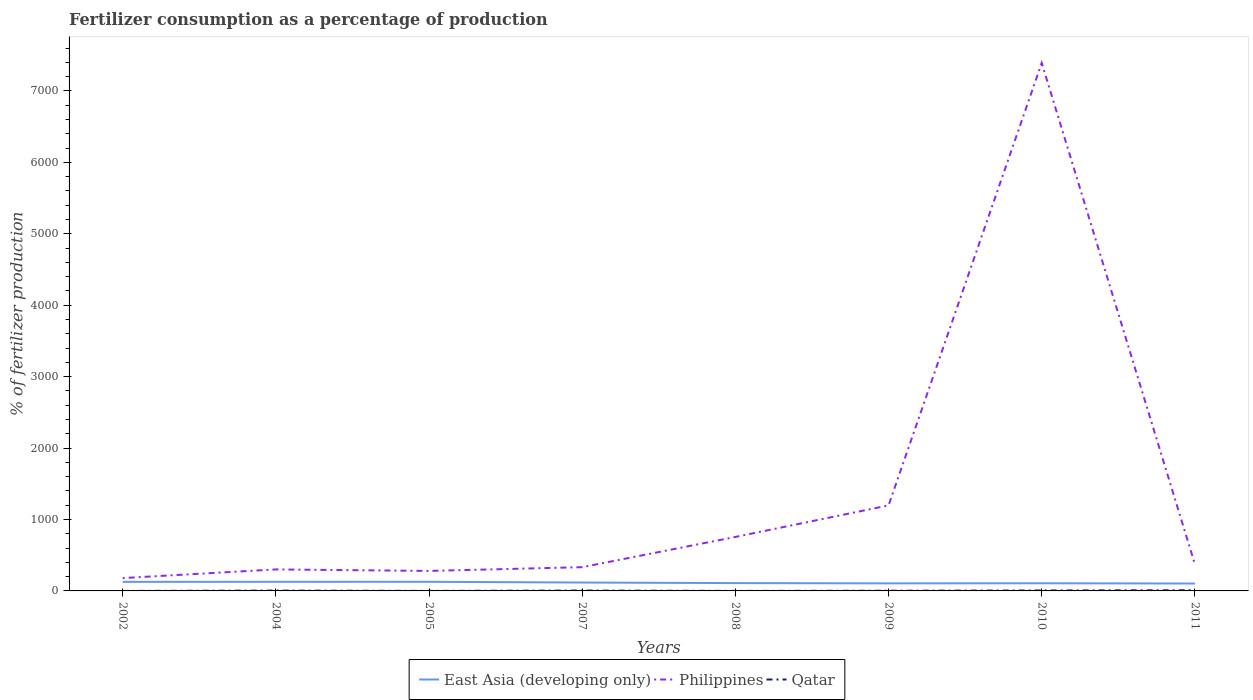How many different coloured lines are there?
Your answer should be compact. 3. Across all years, what is the maximum percentage of fertilizers consumed in Qatar?
Make the answer very short. 0.06. What is the total percentage of fertilizers consumed in Qatar in the graph?
Ensure brevity in your answer.  -5.1. What is the difference between the highest and the second highest percentage of fertilizers consumed in Qatar?
Offer a very short reply. 9.68. What is the difference between the highest and the lowest percentage of fertilizers consumed in Philippines?
Your answer should be very brief. 1. How many lines are there?
Your answer should be very brief. 3. How many years are there in the graph?
Keep it short and to the point. 8. Does the graph contain any zero values?
Ensure brevity in your answer.  No. Does the graph contain grids?
Your answer should be compact. No. Where does the legend appear in the graph?
Give a very brief answer. Bottom center. How many legend labels are there?
Ensure brevity in your answer.  3. How are the legend labels stacked?
Provide a short and direct response. Horizontal. What is the title of the graph?
Offer a terse response. Fertilizer consumption as a percentage of production. Does "France" appear as one of the legend labels in the graph?
Keep it short and to the point. No. What is the label or title of the Y-axis?
Ensure brevity in your answer.  % of fertilizer production. What is the % of fertilizer production of East Asia (developing only) in 2002?
Offer a very short reply. 127.14. What is the % of fertilizer production of Philippines in 2002?
Your answer should be very brief. 179.9. What is the % of fertilizer production in Qatar in 2002?
Your answer should be very brief. 0.06. What is the % of fertilizer production of East Asia (developing only) in 2004?
Provide a succinct answer. 127.47. What is the % of fertilizer production in Philippines in 2004?
Your response must be concise. 301.04. What is the % of fertilizer production in Qatar in 2004?
Give a very brief answer. 4.79. What is the % of fertilizer production of East Asia (developing only) in 2005?
Your response must be concise. 127.76. What is the % of fertilizer production of Philippines in 2005?
Keep it short and to the point. 280.04. What is the % of fertilizer production of Qatar in 2005?
Your response must be concise. 0.54. What is the % of fertilizer production of East Asia (developing only) in 2007?
Offer a terse response. 117.36. What is the % of fertilizer production in Philippines in 2007?
Provide a short and direct response. 332.59. What is the % of fertilizer production in Qatar in 2007?
Your answer should be very brief. 5.16. What is the % of fertilizer production in East Asia (developing only) in 2008?
Ensure brevity in your answer.  109.65. What is the % of fertilizer production in Philippines in 2008?
Your answer should be very brief. 755.74. What is the % of fertilizer production in Qatar in 2008?
Give a very brief answer. 0.26. What is the % of fertilizer production in East Asia (developing only) in 2009?
Make the answer very short. 105.86. What is the % of fertilizer production in Philippines in 2009?
Your answer should be very brief. 1197.15. What is the % of fertilizer production in Qatar in 2009?
Give a very brief answer. 2.78. What is the % of fertilizer production of East Asia (developing only) in 2010?
Provide a succinct answer. 107.14. What is the % of fertilizer production in Philippines in 2010?
Offer a very short reply. 7391.18. What is the % of fertilizer production of Qatar in 2010?
Offer a very short reply. 6.17. What is the % of fertilizer production in East Asia (developing only) in 2011?
Keep it short and to the point. 103.65. What is the % of fertilizer production in Philippines in 2011?
Your answer should be very brief. 374.92. What is the % of fertilizer production in Qatar in 2011?
Your response must be concise. 9.75. Across all years, what is the maximum % of fertilizer production in East Asia (developing only)?
Offer a very short reply. 127.76. Across all years, what is the maximum % of fertilizer production of Philippines?
Your response must be concise. 7391.18. Across all years, what is the maximum % of fertilizer production in Qatar?
Your response must be concise. 9.75. Across all years, what is the minimum % of fertilizer production in East Asia (developing only)?
Offer a very short reply. 103.65. Across all years, what is the minimum % of fertilizer production in Philippines?
Provide a succinct answer. 179.9. Across all years, what is the minimum % of fertilizer production in Qatar?
Make the answer very short. 0.06. What is the total % of fertilizer production of East Asia (developing only) in the graph?
Ensure brevity in your answer.  926.02. What is the total % of fertilizer production of Philippines in the graph?
Give a very brief answer. 1.08e+04. What is the total % of fertilizer production of Qatar in the graph?
Offer a terse response. 29.52. What is the difference between the % of fertilizer production in East Asia (developing only) in 2002 and that in 2004?
Make the answer very short. -0.33. What is the difference between the % of fertilizer production in Philippines in 2002 and that in 2004?
Provide a succinct answer. -121.14. What is the difference between the % of fertilizer production in Qatar in 2002 and that in 2004?
Your answer should be very brief. -4.73. What is the difference between the % of fertilizer production in East Asia (developing only) in 2002 and that in 2005?
Offer a very short reply. -0.62. What is the difference between the % of fertilizer production in Philippines in 2002 and that in 2005?
Keep it short and to the point. -100.14. What is the difference between the % of fertilizer production in Qatar in 2002 and that in 2005?
Provide a succinct answer. -0.47. What is the difference between the % of fertilizer production in East Asia (developing only) in 2002 and that in 2007?
Provide a succinct answer. 9.77. What is the difference between the % of fertilizer production in Philippines in 2002 and that in 2007?
Your response must be concise. -152.69. What is the difference between the % of fertilizer production in Qatar in 2002 and that in 2007?
Your answer should be very brief. -5.1. What is the difference between the % of fertilizer production in East Asia (developing only) in 2002 and that in 2008?
Offer a terse response. 17.49. What is the difference between the % of fertilizer production of Philippines in 2002 and that in 2008?
Give a very brief answer. -575.84. What is the difference between the % of fertilizer production of Qatar in 2002 and that in 2008?
Offer a terse response. -0.2. What is the difference between the % of fertilizer production in East Asia (developing only) in 2002 and that in 2009?
Give a very brief answer. 21.28. What is the difference between the % of fertilizer production of Philippines in 2002 and that in 2009?
Make the answer very short. -1017.25. What is the difference between the % of fertilizer production in Qatar in 2002 and that in 2009?
Give a very brief answer. -2.71. What is the difference between the % of fertilizer production in East Asia (developing only) in 2002 and that in 2010?
Provide a succinct answer. 20. What is the difference between the % of fertilizer production in Philippines in 2002 and that in 2010?
Offer a very short reply. -7211.28. What is the difference between the % of fertilizer production of Qatar in 2002 and that in 2010?
Ensure brevity in your answer.  -6.11. What is the difference between the % of fertilizer production in East Asia (developing only) in 2002 and that in 2011?
Offer a very short reply. 23.48. What is the difference between the % of fertilizer production of Philippines in 2002 and that in 2011?
Make the answer very short. -195.02. What is the difference between the % of fertilizer production of Qatar in 2002 and that in 2011?
Keep it short and to the point. -9.68. What is the difference between the % of fertilizer production in East Asia (developing only) in 2004 and that in 2005?
Your answer should be compact. -0.29. What is the difference between the % of fertilizer production in Philippines in 2004 and that in 2005?
Offer a very short reply. 21. What is the difference between the % of fertilizer production in Qatar in 2004 and that in 2005?
Your answer should be very brief. 4.26. What is the difference between the % of fertilizer production of East Asia (developing only) in 2004 and that in 2007?
Give a very brief answer. 10.11. What is the difference between the % of fertilizer production in Philippines in 2004 and that in 2007?
Your answer should be compact. -31.55. What is the difference between the % of fertilizer production of Qatar in 2004 and that in 2007?
Your answer should be compact. -0.37. What is the difference between the % of fertilizer production in East Asia (developing only) in 2004 and that in 2008?
Provide a succinct answer. 17.82. What is the difference between the % of fertilizer production in Philippines in 2004 and that in 2008?
Your response must be concise. -454.7. What is the difference between the % of fertilizer production in Qatar in 2004 and that in 2008?
Offer a very short reply. 4.53. What is the difference between the % of fertilizer production of East Asia (developing only) in 2004 and that in 2009?
Ensure brevity in your answer.  21.61. What is the difference between the % of fertilizer production of Philippines in 2004 and that in 2009?
Your answer should be compact. -896.11. What is the difference between the % of fertilizer production in Qatar in 2004 and that in 2009?
Provide a short and direct response. 2.02. What is the difference between the % of fertilizer production in East Asia (developing only) in 2004 and that in 2010?
Offer a very short reply. 20.33. What is the difference between the % of fertilizer production in Philippines in 2004 and that in 2010?
Offer a terse response. -7090.14. What is the difference between the % of fertilizer production in Qatar in 2004 and that in 2010?
Provide a short and direct response. -1.38. What is the difference between the % of fertilizer production in East Asia (developing only) in 2004 and that in 2011?
Provide a short and direct response. 23.81. What is the difference between the % of fertilizer production of Philippines in 2004 and that in 2011?
Provide a short and direct response. -73.88. What is the difference between the % of fertilizer production of Qatar in 2004 and that in 2011?
Provide a short and direct response. -4.96. What is the difference between the % of fertilizer production in East Asia (developing only) in 2005 and that in 2007?
Offer a very short reply. 10.39. What is the difference between the % of fertilizer production of Philippines in 2005 and that in 2007?
Provide a short and direct response. -52.55. What is the difference between the % of fertilizer production of Qatar in 2005 and that in 2007?
Keep it short and to the point. -4.63. What is the difference between the % of fertilizer production in East Asia (developing only) in 2005 and that in 2008?
Keep it short and to the point. 18.11. What is the difference between the % of fertilizer production of Philippines in 2005 and that in 2008?
Your response must be concise. -475.7. What is the difference between the % of fertilizer production of Qatar in 2005 and that in 2008?
Your response must be concise. 0.28. What is the difference between the % of fertilizer production in East Asia (developing only) in 2005 and that in 2009?
Provide a short and direct response. 21.9. What is the difference between the % of fertilizer production of Philippines in 2005 and that in 2009?
Keep it short and to the point. -917.11. What is the difference between the % of fertilizer production of Qatar in 2005 and that in 2009?
Offer a terse response. -2.24. What is the difference between the % of fertilizer production in East Asia (developing only) in 2005 and that in 2010?
Your answer should be compact. 20.62. What is the difference between the % of fertilizer production of Philippines in 2005 and that in 2010?
Provide a short and direct response. -7111.14. What is the difference between the % of fertilizer production in Qatar in 2005 and that in 2010?
Offer a terse response. -5.64. What is the difference between the % of fertilizer production in East Asia (developing only) in 2005 and that in 2011?
Your answer should be compact. 24.1. What is the difference between the % of fertilizer production of Philippines in 2005 and that in 2011?
Give a very brief answer. -94.88. What is the difference between the % of fertilizer production in Qatar in 2005 and that in 2011?
Provide a succinct answer. -9.21. What is the difference between the % of fertilizer production in East Asia (developing only) in 2007 and that in 2008?
Give a very brief answer. 7.72. What is the difference between the % of fertilizer production in Philippines in 2007 and that in 2008?
Make the answer very short. -423.15. What is the difference between the % of fertilizer production in Qatar in 2007 and that in 2008?
Your answer should be very brief. 4.9. What is the difference between the % of fertilizer production of East Asia (developing only) in 2007 and that in 2009?
Provide a succinct answer. 11.51. What is the difference between the % of fertilizer production of Philippines in 2007 and that in 2009?
Your answer should be very brief. -864.56. What is the difference between the % of fertilizer production of Qatar in 2007 and that in 2009?
Your answer should be compact. 2.38. What is the difference between the % of fertilizer production in East Asia (developing only) in 2007 and that in 2010?
Ensure brevity in your answer.  10.22. What is the difference between the % of fertilizer production in Philippines in 2007 and that in 2010?
Make the answer very short. -7058.59. What is the difference between the % of fertilizer production of Qatar in 2007 and that in 2010?
Offer a terse response. -1.01. What is the difference between the % of fertilizer production of East Asia (developing only) in 2007 and that in 2011?
Keep it short and to the point. 13.71. What is the difference between the % of fertilizer production in Philippines in 2007 and that in 2011?
Offer a very short reply. -42.33. What is the difference between the % of fertilizer production of Qatar in 2007 and that in 2011?
Your answer should be very brief. -4.59. What is the difference between the % of fertilizer production of East Asia (developing only) in 2008 and that in 2009?
Offer a very short reply. 3.79. What is the difference between the % of fertilizer production of Philippines in 2008 and that in 2009?
Offer a very short reply. -441.41. What is the difference between the % of fertilizer production in Qatar in 2008 and that in 2009?
Ensure brevity in your answer.  -2.52. What is the difference between the % of fertilizer production in East Asia (developing only) in 2008 and that in 2010?
Your answer should be very brief. 2.51. What is the difference between the % of fertilizer production of Philippines in 2008 and that in 2010?
Give a very brief answer. -6635.44. What is the difference between the % of fertilizer production in Qatar in 2008 and that in 2010?
Offer a very short reply. -5.91. What is the difference between the % of fertilizer production of East Asia (developing only) in 2008 and that in 2011?
Make the answer very short. 5.99. What is the difference between the % of fertilizer production in Philippines in 2008 and that in 2011?
Ensure brevity in your answer.  380.82. What is the difference between the % of fertilizer production in Qatar in 2008 and that in 2011?
Keep it short and to the point. -9.49. What is the difference between the % of fertilizer production of East Asia (developing only) in 2009 and that in 2010?
Provide a succinct answer. -1.29. What is the difference between the % of fertilizer production in Philippines in 2009 and that in 2010?
Offer a terse response. -6194.03. What is the difference between the % of fertilizer production in Qatar in 2009 and that in 2010?
Your response must be concise. -3.4. What is the difference between the % of fertilizer production of East Asia (developing only) in 2009 and that in 2011?
Offer a very short reply. 2.2. What is the difference between the % of fertilizer production in Philippines in 2009 and that in 2011?
Provide a short and direct response. 822.23. What is the difference between the % of fertilizer production in Qatar in 2009 and that in 2011?
Ensure brevity in your answer.  -6.97. What is the difference between the % of fertilizer production of East Asia (developing only) in 2010 and that in 2011?
Ensure brevity in your answer.  3.49. What is the difference between the % of fertilizer production of Philippines in 2010 and that in 2011?
Ensure brevity in your answer.  7016.26. What is the difference between the % of fertilizer production in Qatar in 2010 and that in 2011?
Keep it short and to the point. -3.57. What is the difference between the % of fertilizer production in East Asia (developing only) in 2002 and the % of fertilizer production in Philippines in 2004?
Offer a terse response. -173.9. What is the difference between the % of fertilizer production of East Asia (developing only) in 2002 and the % of fertilizer production of Qatar in 2004?
Provide a succinct answer. 122.34. What is the difference between the % of fertilizer production of Philippines in 2002 and the % of fertilizer production of Qatar in 2004?
Offer a terse response. 175.11. What is the difference between the % of fertilizer production in East Asia (developing only) in 2002 and the % of fertilizer production in Philippines in 2005?
Offer a terse response. -152.9. What is the difference between the % of fertilizer production in East Asia (developing only) in 2002 and the % of fertilizer production in Qatar in 2005?
Provide a succinct answer. 126.6. What is the difference between the % of fertilizer production in Philippines in 2002 and the % of fertilizer production in Qatar in 2005?
Give a very brief answer. 179.36. What is the difference between the % of fertilizer production of East Asia (developing only) in 2002 and the % of fertilizer production of Philippines in 2007?
Provide a short and direct response. -205.45. What is the difference between the % of fertilizer production in East Asia (developing only) in 2002 and the % of fertilizer production in Qatar in 2007?
Offer a terse response. 121.97. What is the difference between the % of fertilizer production of Philippines in 2002 and the % of fertilizer production of Qatar in 2007?
Make the answer very short. 174.74. What is the difference between the % of fertilizer production of East Asia (developing only) in 2002 and the % of fertilizer production of Philippines in 2008?
Provide a short and direct response. -628.6. What is the difference between the % of fertilizer production in East Asia (developing only) in 2002 and the % of fertilizer production in Qatar in 2008?
Offer a terse response. 126.88. What is the difference between the % of fertilizer production of Philippines in 2002 and the % of fertilizer production of Qatar in 2008?
Your answer should be very brief. 179.64. What is the difference between the % of fertilizer production in East Asia (developing only) in 2002 and the % of fertilizer production in Philippines in 2009?
Keep it short and to the point. -1070.01. What is the difference between the % of fertilizer production of East Asia (developing only) in 2002 and the % of fertilizer production of Qatar in 2009?
Provide a short and direct response. 124.36. What is the difference between the % of fertilizer production in Philippines in 2002 and the % of fertilizer production in Qatar in 2009?
Provide a succinct answer. 177.12. What is the difference between the % of fertilizer production in East Asia (developing only) in 2002 and the % of fertilizer production in Philippines in 2010?
Provide a succinct answer. -7264.04. What is the difference between the % of fertilizer production of East Asia (developing only) in 2002 and the % of fertilizer production of Qatar in 2010?
Ensure brevity in your answer.  120.96. What is the difference between the % of fertilizer production of Philippines in 2002 and the % of fertilizer production of Qatar in 2010?
Offer a very short reply. 173.73. What is the difference between the % of fertilizer production of East Asia (developing only) in 2002 and the % of fertilizer production of Philippines in 2011?
Your answer should be compact. -247.78. What is the difference between the % of fertilizer production of East Asia (developing only) in 2002 and the % of fertilizer production of Qatar in 2011?
Offer a very short reply. 117.39. What is the difference between the % of fertilizer production in Philippines in 2002 and the % of fertilizer production in Qatar in 2011?
Make the answer very short. 170.15. What is the difference between the % of fertilizer production of East Asia (developing only) in 2004 and the % of fertilizer production of Philippines in 2005?
Offer a terse response. -152.57. What is the difference between the % of fertilizer production of East Asia (developing only) in 2004 and the % of fertilizer production of Qatar in 2005?
Ensure brevity in your answer.  126.93. What is the difference between the % of fertilizer production in Philippines in 2004 and the % of fertilizer production in Qatar in 2005?
Keep it short and to the point. 300.5. What is the difference between the % of fertilizer production of East Asia (developing only) in 2004 and the % of fertilizer production of Philippines in 2007?
Ensure brevity in your answer.  -205.12. What is the difference between the % of fertilizer production in East Asia (developing only) in 2004 and the % of fertilizer production in Qatar in 2007?
Offer a terse response. 122.31. What is the difference between the % of fertilizer production of Philippines in 2004 and the % of fertilizer production of Qatar in 2007?
Give a very brief answer. 295.88. What is the difference between the % of fertilizer production in East Asia (developing only) in 2004 and the % of fertilizer production in Philippines in 2008?
Give a very brief answer. -628.27. What is the difference between the % of fertilizer production of East Asia (developing only) in 2004 and the % of fertilizer production of Qatar in 2008?
Provide a short and direct response. 127.21. What is the difference between the % of fertilizer production in Philippines in 2004 and the % of fertilizer production in Qatar in 2008?
Offer a terse response. 300.78. What is the difference between the % of fertilizer production of East Asia (developing only) in 2004 and the % of fertilizer production of Philippines in 2009?
Make the answer very short. -1069.68. What is the difference between the % of fertilizer production of East Asia (developing only) in 2004 and the % of fertilizer production of Qatar in 2009?
Provide a succinct answer. 124.69. What is the difference between the % of fertilizer production in Philippines in 2004 and the % of fertilizer production in Qatar in 2009?
Your answer should be very brief. 298.26. What is the difference between the % of fertilizer production of East Asia (developing only) in 2004 and the % of fertilizer production of Philippines in 2010?
Your answer should be very brief. -7263.71. What is the difference between the % of fertilizer production of East Asia (developing only) in 2004 and the % of fertilizer production of Qatar in 2010?
Give a very brief answer. 121.29. What is the difference between the % of fertilizer production of Philippines in 2004 and the % of fertilizer production of Qatar in 2010?
Provide a succinct answer. 294.87. What is the difference between the % of fertilizer production of East Asia (developing only) in 2004 and the % of fertilizer production of Philippines in 2011?
Provide a short and direct response. -247.45. What is the difference between the % of fertilizer production of East Asia (developing only) in 2004 and the % of fertilizer production of Qatar in 2011?
Offer a terse response. 117.72. What is the difference between the % of fertilizer production in Philippines in 2004 and the % of fertilizer production in Qatar in 2011?
Ensure brevity in your answer.  291.29. What is the difference between the % of fertilizer production of East Asia (developing only) in 2005 and the % of fertilizer production of Philippines in 2007?
Offer a very short reply. -204.83. What is the difference between the % of fertilizer production in East Asia (developing only) in 2005 and the % of fertilizer production in Qatar in 2007?
Offer a very short reply. 122.59. What is the difference between the % of fertilizer production of Philippines in 2005 and the % of fertilizer production of Qatar in 2007?
Your answer should be very brief. 274.88. What is the difference between the % of fertilizer production in East Asia (developing only) in 2005 and the % of fertilizer production in Philippines in 2008?
Provide a succinct answer. -627.98. What is the difference between the % of fertilizer production of East Asia (developing only) in 2005 and the % of fertilizer production of Qatar in 2008?
Your answer should be very brief. 127.5. What is the difference between the % of fertilizer production of Philippines in 2005 and the % of fertilizer production of Qatar in 2008?
Your answer should be compact. 279.78. What is the difference between the % of fertilizer production of East Asia (developing only) in 2005 and the % of fertilizer production of Philippines in 2009?
Offer a very short reply. -1069.39. What is the difference between the % of fertilizer production in East Asia (developing only) in 2005 and the % of fertilizer production in Qatar in 2009?
Provide a short and direct response. 124.98. What is the difference between the % of fertilizer production in Philippines in 2005 and the % of fertilizer production in Qatar in 2009?
Keep it short and to the point. 277.26. What is the difference between the % of fertilizer production of East Asia (developing only) in 2005 and the % of fertilizer production of Philippines in 2010?
Offer a terse response. -7263.42. What is the difference between the % of fertilizer production in East Asia (developing only) in 2005 and the % of fertilizer production in Qatar in 2010?
Ensure brevity in your answer.  121.58. What is the difference between the % of fertilizer production in Philippines in 2005 and the % of fertilizer production in Qatar in 2010?
Your answer should be very brief. 273.87. What is the difference between the % of fertilizer production of East Asia (developing only) in 2005 and the % of fertilizer production of Philippines in 2011?
Give a very brief answer. -247.16. What is the difference between the % of fertilizer production of East Asia (developing only) in 2005 and the % of fertilizer production of Qatar in 2011?
Give a very brief answer. 118.01. What is the difference between the % of fertilizer production of Philippines in 2005 and the % of fertilizer production of Qatar in 2011?
Provide a short and direct response. 270.29. What is the difference between the % of fertilizer production in East Asia (developing only) in 2007 and the % of fertilizer production in Philippines in 2008?
Give a very brief answer. -638.38. What is the difference between the % of fertilizer production in East Asia (developing only) in 2007 and the % of fertilizer production in Qatar in 2008?
Your answer should be very brief. 117.1. What is the difference between the % of fertilizer production of Philippines in 2007 and the % of fertilizer production of Qatar in 2008?
Keep it short and to the point. 332.32. What is the difference between the % of fertilizer production in East Asia (developing only) in 2007 and the % of fertilizer production in Philippines in 2009?
Your answer should be very brief. -1079.79. What is the difference between the % of fertilizer production in East Asia (developing only) in 2007 and the % of fertilizer production in Qatar in 2009?
Your answer should be very brief. 114.59. What is the difference between the % of fertilizer production of Philippines in 2007 and the % of fertilizer production of Qatar in 2009?
Provide a succinct answer. 329.81. What is the difference between the % of fertilizer production in East Asia (developing only) in 2007 and the % of fertilizer production in Philippines in 2010?
Keep it short and to the point. -7273.81. What is the difference between the % of fertilizer production of East Asia (developing only) in 2007 and the % of fertilizer production of Qatar in 2010?
Your answer should be very brief. 111.19. What is the difference between the % of fertilizer production in Philippines in 2007 and the % of fertilizer production in Qatar in 2010?
Your answer should be very brief. 326.41. What is the difference between the % of fertilizer production of East Asia (developing only) in 2007 and the % of fertilizer production of Philippines in 2011?
Provide a short and direct response. -257.55. What is the difference between the % of fertilizer production of East Asia (developing only) in 2007 and the % of fertilizer production of Qatar in 2011?
Ensure brevity in your answer.  107.61. What is the difference between the % of fertilizer production in Philippines in 2007 and the % of fertilizer production in Qatar in 2011?
Make the answer very short. 322.84. What is the difference between the % of fertilizer production of East Asia (developing only) in 2008 and the % of fertilizer production of Philippines in 2009?
Keep it short and to the point. -1087.5. What is the difference between the % of fertilizer production of East Asia (developing only) in 2008 and the % of fertilizer production of Qatar in 2009?
Your answer should be compact. 106.87. What is the difference between the % of fertilizer production in Philippines in 2008 and the % of fertilizer production in Qatar in 2009?
Your answer should be compact. 752.96. What is the difference between the % of fertilizer production of East Asia (developing only) in 2008 and the % of fertilizer production of Philippines in 2010?
Provide a short and direct response. -7281.53. What is the difference between the % of fertilizer production in East Asia (developing only) in 2008 and the % of fertilizer production in Qatar in 2010?
Give a very brief answer. 103.47. What is the difference between the % of fertilizer production in Philippines in 2008 and the % of fertilizer production in Qatar in 2010?
Give a very brief answer. 749.57. What is the difference between the % of fertilizer production in East Asia (developing only) in 2008 and the % of fertilizer production in Philippines in 2011?
Give a very brief answer. -265.27. What is the difference between the % of fertilizer production of East Asia (developing only) in 2008 and the % of fertilizer production of Qatar in 2011?
Offer a terse response. 99.9. What is the difference between the % of fertilizer production in Philippines in 2008 and the % of fertilizer production in Qatar in 2011?
Provide a short and direct response. 745.99. What is the difference between the % of fertilizer production in East Asia (developing only) in 2009 and the % of fertilizer production in Philippines in 2010?
Ensure brevity in your answer.  -7285.32. What is the difference between the % of fertilizer production of East Asia (developing only) in 2009 and the % of fertilizer production of Qatar in 2010?
Provide a short and direct response. 99.68. What is the difference between the % of fertilizer production of Philippines in 2009 and the % of fertilizer production of Qatar in 2010?
Provide a short and direct response. 1190.97. What is the difference between the % of fertilizer production of East Asia (developing only) in 2009 and the % of fertilizer production of Philippines in 2011?
Your response must be concise. -269.06. What is the difference between the % of fertilizer production in East Asia (developing only) in 2009 and the % of fertilizer production in Qatar in 2011?
Offer a very short reply. 96.11. What is the difference between the % of fertilizer production in Philippines in 2009 and the % of fertilizer production in Qatar in 2011?
Make the answer very short. 1187.4. What is the difference between the % of fertilizer production of East Asia (developing only) in 2010 and the % of fertilizer production of Philippines in 2011?
Provide a short and direct response. -267.78. What is the difference between the % of fertilizer production in East Asia (developing only) in 2010 and the % of fertilizer production in Qatar in 2011?
Your response must be concise. 97.39. What is the difference between the % of fertilizer production of Philippines in 2010 and the % of fertilizer production of Qatar in 2011?
Give a very brief answer. 7381.43. What is the average % of fertilizer production of East Asia (developing only) per year?
Provide a succinct answer. 115.75. What is the average % of fertilizer production of Philippines per year?
Offer a very short reply. 1351.57. What is the average % of fertilizer production in Qatar per year?
Make the answer very short. 3.69. In the year 2002, what is the difference between the % of fertilizer production of East Asia (developing only) and % of fertilizer production of Philippines?
Provide a short and direct response. -52.76. In the year 2002, what is the difference between the % of fertilizer production in East Asia (developing only) and % of fertilizer production in Qatar?
Make the answer very short. 127.07. In the year 2002, what is the difference between the % of fertilizer production in Philippines and % of fertilizer production in Qatar?
Ensure brevity in your answer.  179.84. In the year 2004, what is the difference between the % of fertilizer production of East Asia (developing only) and % of fertilizer production of Philippines?
Give a very brief answer. -173.57. In the year 2004, what is the difference between the % of fertilizer production of East Asia (developing only) and % of fertilizer production of Qatar?
Your answer should be very brief. 122.68. In the year 2004, what is the difference between the % of fertilizer production in Philippines and % of fertilizer production in Qatar?
Offer a terse response. 296.25. In the year 2005, what is the difference between the % of fertilizer production in East Asia (developing only) and % of fertilizer production in Philippines?
Offer a very short reply. -152.28. In the year 2005, what is the difference between the % of fertilizer production of East Asia (developing only) and % of fertilizer production of Qatar?
Your response must be concise. 127.22. In the year 2005, what is the difference between the % of fertilizer production in Philippines and % of fertilizer production in Qatar?
Your answer should be very brief. 279.5. In the year 2007, what is the difference between the % of fertilizer production of East Asia (developing only) and % of fertilizer production of Philippines?
Ensure brevity in your answer.  -215.22. In the year 2007, what is the difference between the % of fertilizer production of East Asia (developing only) and % of fertilizer production of Qatar?
Your response must be concise. 112.2. In the year 2007, what is the difference between the % of fertilizer production in Philippines and % of fertilizer production in Qatar?
Offer a terse response. 327.42. In the year 2008, what is the difference between the % of fertilizer production in East Asia (developing only) and % of fertilizer production in Philippines?
Keep it short and to the point. -646.09. In the year 2008, what is the difference between the % of fertilizer production of East Asia (developing only) and % of fertilizer production of Qatar?
Provide a succinct answer. 109.39. In the year 2008, what is the difference between the % of fertilizer production of Philippines and % of fertilizer production of Qatar?
Your answer should be compact. 755.48. In the year 2009, what is the difference between the % of fertilizer production in East Asia (developing only) and % of fertilizer production in Philippines?
Make the answer very short. -1091.29. In the year 2009, what is the difference between the % of fertilizer production of East Asia (developing only) and % of fertilizer production of Qatar?
Provide a short and direct response. 103.08. In the year 2009, what is the difference between the % of fertilizer production of Philippines and % of fertilizer production of Qatar?
Ensure brevity in your answer.  1194.37. In the year 2010, what is the difference between the % of fertilizer production in East Asia (developing only) and % of fertilizer production in Philippines?
Keep it short and to the point. -7284.04. In the year 2010, what is the difference between the % of fertilizer production of East Asia (developing only) and % of fertilizer production of Qatar?
Your response must be concise. 100.97. In the year 2010, what is the difference between the % of fertilizer production of Philippines and % of fertilizer production of Qatar?
Your response must be concise. 7385. In the year 2011, what is the difference between the % of fertilizer production of East Asia (developing only) and % of fertilizer production of Philippines?
Make the answer very short. -271.26. In the year 2011, what is the difference between the % of fertilizer production of East Asia (developing only) and % of fertilizer production of Qatar?
Make the answer very short. 93.91. In the year 2011, what is the difference between the % of fertilizer production of Philippines and % of fertilizer production of Qatar?
Your response must be concise. 365.17. What is the ratio of the % of fertilizer production in East Asia (developing only) in 2002 to that in 2004?
Your response must be concise. 1. What is the ratio of the % of fertilizer production of Philippines in 2002 to that in 2004?
Keep it short and to the point. 0.6. What is the ratio of the % of fertilizer production of Qatar in 2002 to that in 2004?
Ensure brevity in your answer.  0.01. What is the ratio of the % of fertilizer production of Philippines in 2002 to that in 2005?
Provide a short and direct response. 0.64. What is the ratio of the % of fertilizer production in Qatar in 2002 to that in 2005?
Provide a succinct answer. 0.12. What is the ratio of the % of fertilizer production in Philippines in 2002 to that in 2007?
Provide a succinct answer. 0.54. What is the ratio of the % of fertilizer production of Qatar in 2002 to that in 2007?
Ensure brevity in your answer.  0.01. What is the ratio of the % of fertilizer production of East Asia (developing only) in 2002 to that in 2008?
Your answer should be compact. 1.16. What is the ratio of the % of fertilizer production in Philippines in 2002 to that in 2008?
Make the answer very short. 0.24. What is the ratio of the % of fertilizer production of Qatar in 2002 to that in 2008?
Give a very brief answer. 0.24. What is the ratio of the % of fertilizer production of East Asia (developing only) in 2002 to that in 2009?
Give a very brief answer. 1.2. What is the ratio of the % of fertilizer production of Philippines in 2002 to that in 2009?
Provide a short and direct response. 0.15. What is the ratio of the % of fertilizer production in Qatar in 2002 to that in 2009?
Your response must be concise. 0.02. What is the ratio of the % of fertilizer production in East Asia (developing only) in 2002 to that in 2010?
Offer a terse response. 1.19. What is the ratio of the % of fertilizer production of Philippines in 2002 to that in 2010?
Give a very brief answer. 0.02. What is the ratio of the % of fertilizer production of Qatar in 2002 to that in 2010?
Provide a short and direct response. 0.01. What is the ratio of the % of fertilizer production of East Asia (developing only) in 2002 to that in 2011?
Your response must be concise. 1.23. What is the ratio of the % of fertilizer production in Philippines in 2002 to that in 2011?
Ensure brevity in your answer.  0.48. What is the ratio of the % of fertilizer production in Qatar in 2002 to that in 2011?
Your answer should be compact. 0.01. What is the ratio of the % of fertilizer production of East Asia (developing only) in 2004 to that in 2005?
Offer a very short reply. 1. What is the ratio of the % of fertilizer production of Philippines in 2004 to that in 2005?
Your answer should be compact. 1.07. What is the ratio of the % of fertilizer production of Qatar in 2004 to that in 2005?
Provide a short and direct response. 8.94. What is the ratio of the % of fertilizer production in East Asia (developing only) in 2004 to that in 2007?
Your answer should be compact. 1.09. What is the ratio of the % of fertilizer production in Philippines in 2004 to that in 2007?
Your response must be concise. 0.91. What is the ratio of the % of fertilizer production in Qatar in 2004 to that in 2007?
Keep it short and to the point. 0.93. What is the ratio of the % of fertilizer production of East Asia (developing only) in 2004 to that in 2008?
Your answer should be very brief. 1.16. What is the ratio of the % of fertilizer production of Philippines in 2004 to that in 2008?
Provide a succinct answer. 0.4. What is the ratio of the % of fertilizer production in Qatar in 2004 to that in 2008?
Your response must be concise. 18.35. What is the ratio of the % of fertilizer production of East Asia (developing only) in 2004 to that in 2009?
Provide a succinct answer. 1.2. What is the ratio of the % of fertilizer production of Philippines in 2004 to that in 2009?
Your answer should be compact. 0.25. What is the ratio of the % of fertilizer production of Qatar in 2004 to that in 2009?
Your answer should be very brief. 1.73. What is the ratio of the % of fertilizer production of East Asia (developing only) in 2004 to that in 2010?
Provide a succinct answer. 1.19. What is the ratio of the % of fertilizer production in Philippines in 2004 to that in 2010?
Make the answer very short. 0.04. What is the ratio of the % of fertilizer production in Qatar in 2004 to that in 2010?
Provide a short and direct response. 0.78. What is the ratio of the % of fertilizer production in East Asia (developing only) in 2004 to that in 2011?
Offer a very short reply. 1.23. What is the ratio of the % of fertilizer production of Philippines in 2004 to that in 2011?
Make the answer very short. 0.8. What is the ratio of the % of fertilizer production of Qatar in 2004 to that in 2011?
Offer a terse response. 0.49. What is the ratio of the % of fertilizer production in East Asia (developing only) in 2005 to that in 2007?
Keep it short and to the point. 1.09. What is the ratio of the % of fertilizer production in Philippines in 2005 to that in 2007?
Your answer should be compact. 0.84. What is the ratio of the % of fertilizer production in Qatar in 2005 to that in 2007?
Make the answer very short. 0.1. What is the ratio of the % of fertilizer production in East Asia (developing only) in 2005 to that in 2008?
Give a very brief answer. 1.17. What is the ratio of the % of fertilizer production in Philippines in 2005 to that in 2008?
Your answer should be very brief. 0.37. What is the ratio of the % of fertilizer production in Qatar in 2005 to that in 2008?
Provide a succinct answer. 2.05. What is the ratio of the % of fertilizer production of East Asia (developing only) in 2005 to that in 2009?
Make the answer very short. 1.21. What is the ratio of the % of fertilizer production of Philippines in 2005 to that in 2009?
Offer a terse response. 0.23. What is the ratio of the % of fertilizer production of Qatar in 2005 to that in 2009?
Your answer should be very brief. 0.19. What is the ratio of the % of fertilizer production in East Asia (developing only) in 2005 to that in 2010?
Your response must be concise. 1.19. What is the ratio of the % of fertilizer production in Philippines in 2005 to that in 2010?
Offer a very short reply. 0.04. What is the ratio of the % of fertilizer production in Qatar in 2005 to that in 2010?
Your answer should be compact. 0.09. What is the ratio of the % of fertilizer production in East Asia (developing only) in 2005 to that in 2011?
Provide a succinct answer. 1.23. What is the ratio of the % of fertilizer production in Philippines in 2005 to that in 2011?
Keep it short and to the point. 0.75. What is the ratio of the % of fertilizer production of Qatar in 2005 to that in 2011?
Make the answer very short. 0.06. What is the ratio of the % of fertilizer production of East Asia (developing only) in 2007 to that in 2008?
Keep it short and to the point. 1.07. What is the ratio of the % of fertilizer production of Philippines in 2007 to that in 2008?
Keep it short and to the point. 0.44. What is the ratio of the % of fertilizer production of Qatar in 2007 to that in 2008?
Offer a very short reply. 19.77. What is the ratio of the % of fertilizer production in East Asia (developing only) in 2007 to that in 2009?
Your answer should be compact. 1.11. What is the ratio of the % of fertilizer production of Philippines in 2007 to that in 2009?
Your answer should be compact. 0.28. What is the ratio of the % of fertilizer production of Qatar in 2007 to that in 2009?
Offer a terse response. 1.86. What is the ratio of the % of fertilizer production in East Asia (developing only) in 2007 to that in 2010?
Your answer should be very brief. 1.1. What is the ratio of the % of fertilizer production of Philippines in 2007 to that in 2010?
Ensure brevity in your answer.  0.04. What is the ratio of the % of fertilizer production of Qatar in 2007 to that in 2010?
Ensure brevity in your answer.  0.84. What is the ratio of the % of fertilizer production of East Asia (developing only) in 2007 to that in 2011?
Ensure brevity in your answer.  1.13. What is the ratio of the % of fertilizer production in Philippines in 2007 to that in 2011?
Your answer should be compact. 0.89. What is the ratio of the % of fertilizer production of Qatar in 2007 to that in 2011?
Your answer should be very brief. 0.53. What is the ratio of the % of fertilizer production in East Asia (developing only) in 2008 to that in 2009?
Your response must be concise. 1.04. What is the ratio of the % of fertilizer production in Philippines in 2008 to that in 2009?
Offer a terse response. 0.63. What is the ratio of the % of fertilizer production of Qatar in 2008 to that in 2009?
Make the answer very short. 0.09. What is the ratio of the % of fertilizer production of East Asia (developing only) in 2008 to that in 2010?
Your answer should be compact. 1.02. What is the ratio of the % of fertilizer production in Philippines in 2008 to that in 2010?
Give a very brief answer. 0.1. What is the ratio of the % of fertilizer production in Qatar in 2008 to that in 2010?
Your answer should be very brief. 0.04. What is the ratio of the % of fertilizer production in East Asia (developing only) in 2008 to that in 2011?
Offer a very short reply. 1.06. What is the ratio of the % of fertilizer production of Philippines in 2008 to that in 2011?
Provide a succinct answer. 2.02. What is the ratio of the % of fertilizer production in Qatar in 2008 to that in 2011?
Your response must be concise. 0.03. What is the ratio of the % of fertilizer production in East Asia (developing only) in 2009 to that in 2010?
Ensure brevity in your answer.  0.99. What is the ratio of the % of fertilizer production in Philippines in 2009 to that in 2010?
Your response must be concise. 0.16. What is the ratio of the % of fertilizer production in Qatar in 2009 to that in 2010?
Your answer should be very brief. 0.45. What is the ratio of the % of fertilizer production of East Asia (developing only) in 2009 to that in 2011?
Your response must be concise. 1.02. What is the ratio of the % of fertilizer production in Philippines in 2009 to that in 2011?
Make the answer very short. 3.19. What is the ratio of the % of fertilizer production in Qatar in 2009 to that in 2011?
Make the answer very short. 0.28. What is the ratio of the % of fertilizer production of East Asia (developing only) in 2010 to that in 2011?
Your answer should be very brief. 1.03. What is the ratio of the % of fertilizer production of Philippines in 2010 to that in 2011?
Give a very brief answer. 19.71. What is the ratio of the % of fertilizer production in Qatar in 2010 to that in 2011?
Ensure brevity in your answer.  0.63. What is the difference between the highest and the second highest % of fertilizer production in East Asia (developing only)?
Ensure brevity in your answer.  0.29. What is the difference between the highest and the second highest % of fertilizer production in Philippines?
Ensure brevity in your answer.  6194.03. What is the difference between the highest and the second highest % of fertilizer production of Qatar?
Ensure brevity in your answer.  3.57. What is the difference between the highest and the lowest % of fertilizer production in East Asia (developing only)?
Give a very brief answer. 24.1. What is the difference between the highest and the lowest % of fertilizer production in Philippines?
Offer a very short reply. 7211.28. What is the difference between the highest and the lowest % of fertilizer production in Qatar?
Keep it short and to the point. 9.68. 